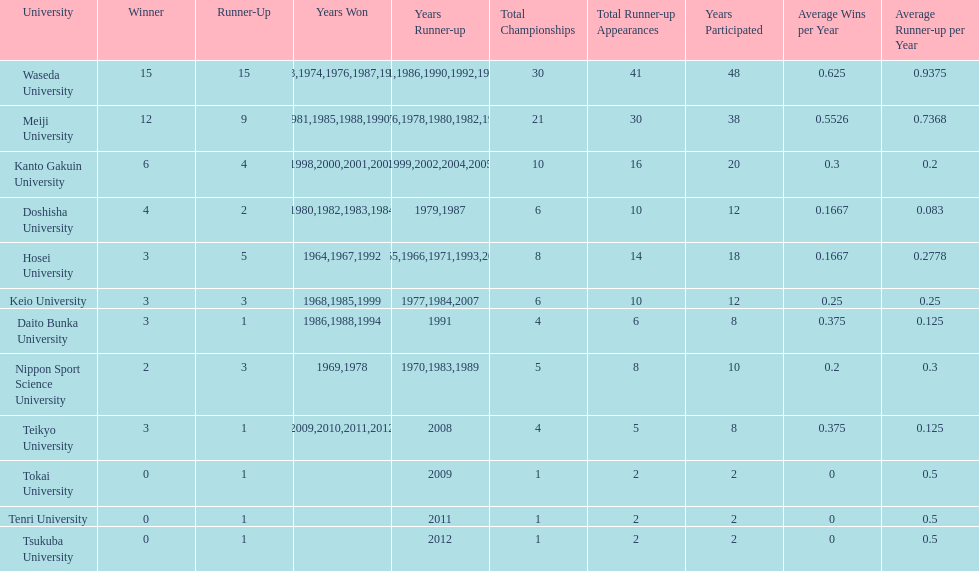Who won the last championship recorded on this table? Teikyo University. 